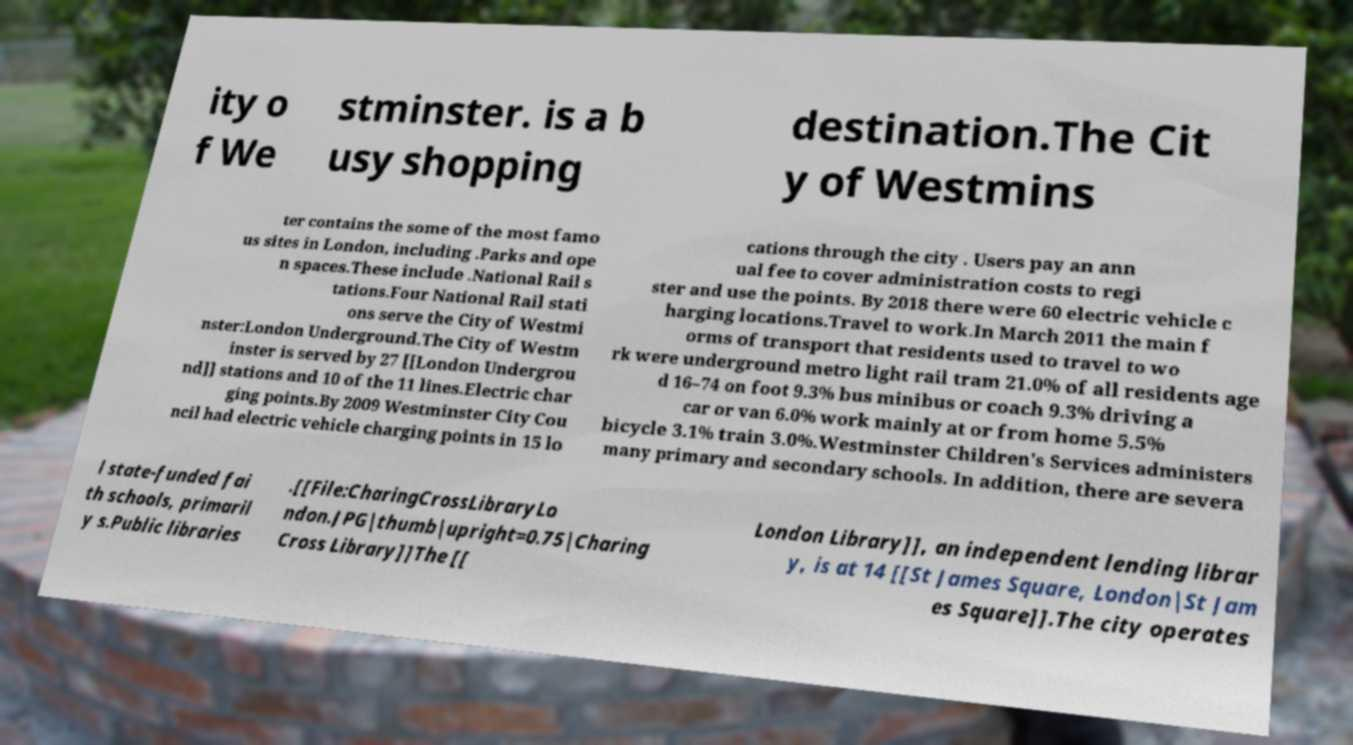I need the written content from this picture converted into text. Can you do that? ity o f We stminster. is a b usy shopping destination.The Cit y of Westmins ter contains the some of the most famo us sites in London, including .Parks and ope n spaces.These include .National Rail s tations.Four National Rail stati ons serve the City of Westmi nster:London Underground.The City of Westm inster is served by 27 [[London Undergrou nd]] stations and 10 of the 11 lines.Electric char ging points.By 2009 Westminster City Cou ncil had electric vehicle charging points in 15 lo cations through the city . Users pay an ann ual fee to cover administration costs to regi ster and use the points. By 2018 there were 60 electric vehicle c harging locations.Travel to work.In March 2011 the main f orms of transport that residents used to travel to wo rk were underground metro light rail tram 21.0% of all residents age d 16–74 on foot 9.3% bus minibus or coach 9.3% driving a car or van 6.0% work mainly at or from home 5.5% bicycle 3.1% train 3.0%.Westminster Children's Services administers many primary and secondary schools. In addition, there are severa l state-funded fai th schools, primaril y s.Public libraries .[[File:CharingCrossLibraryLo ndon.JPG|thumb|upright=0.75|Charing Cross Library]]The [[ London Library]], an independent lending librar y, is at 14 [[St James Square, London|St Jam es Square]].The city operates 